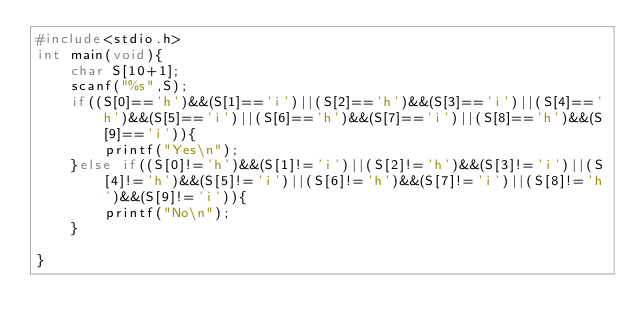Convert code to text. <code><loc_0><loc_0><loc_500><loc_500><_C_>#include<stdio.h>
int main(void){
    char S[10+1];
    scanf("%s",S);
    if((S[0]=='h')&&(S[1]=='i')||(S[2]=='h')&&(S[3]=='i')||(S[4]=='h')&&(S[5]=='i')||(S[6]=='h')&&(S[7]=='i')||(S[8]=='h')&&(S[9]=='i')){
        printf("Yes\n");
    }else if((S[0]!='h')&&(S[1]!='i')||(S[2]!='h')&&(S[3]!='i')||(S[4]!='h')&&(S[5]!='i')||(S[6]!='h')&&(S[7]!='i')||(S[8]!='h')&&(S[9]!='i')){
        printf("No\n");
    }

}</code> 